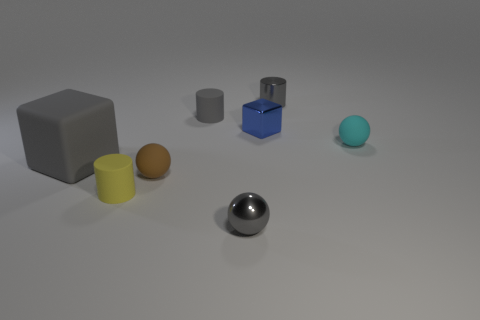There is a big block in front of the sphere behind the big gray matte block; what number of small gray metallic spheres are behind it?
Offer a terse response. 0. Do the tiny metallic cylinder and the tiny shiny block have the same color?
Ensure brevity in your answer.  No. Are there any other metallic cubes that have the same color as the shiny block?
Offer a very short reply. No. What is the color of the metallic ball that is the same size as the blue shiny thing?
Your answer should be compact. Gray. Are there any metal things of the same shape as the big matte object?
Provide a succinct answer. Yes. The big matte thing that is the same color as the shiny cylinder is what shape?
Ensure brevity in your answer.  Cube. There is a gray shiny thing that is behind the block that is behind the large gray matte thing; are there any small yellow rubber cylinders that are on the right side of it?
Ensure brevity in your answer.  No. The blue thing that is the same size as the cyan rubber sphere is what shape?
Make the answer very short. Cube. There is another rubber object that is the same shape as the brown thing; what is its color?
Keep it short and to the point. Cyan. How many things are small cyan spheres or brown balls?
Ensure brevity in your answer.  2. 